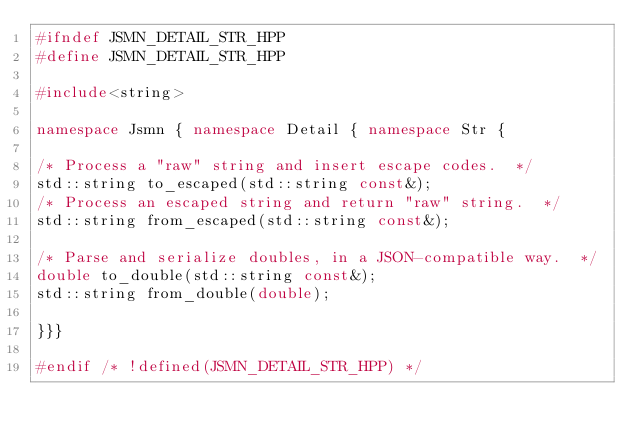<code> <loc_0><loc_0><loc_500><loc_500><_C++_>#ifndef JSMN_DETAIL_STR_HPP
#define JSMN_DETAIL_STR_HPP

#include<string>

namespace Jsmn { namespace Detail { namespace Str {

/* Process a "raw" string and insert escape codes.  */
std::string to_escaped(std::string const&);
/* Process an escaped string and return "raw" string.  */
std::string from_escaped(std::string const&);

/* Parse and serialize doubles, in a JSON-compatible way.  */
double to_double(std::string const&);
std::string from_double(double);

}}}

#endif /* !defined(JSMN_DETAIL_STR_HPP) */
</code> 